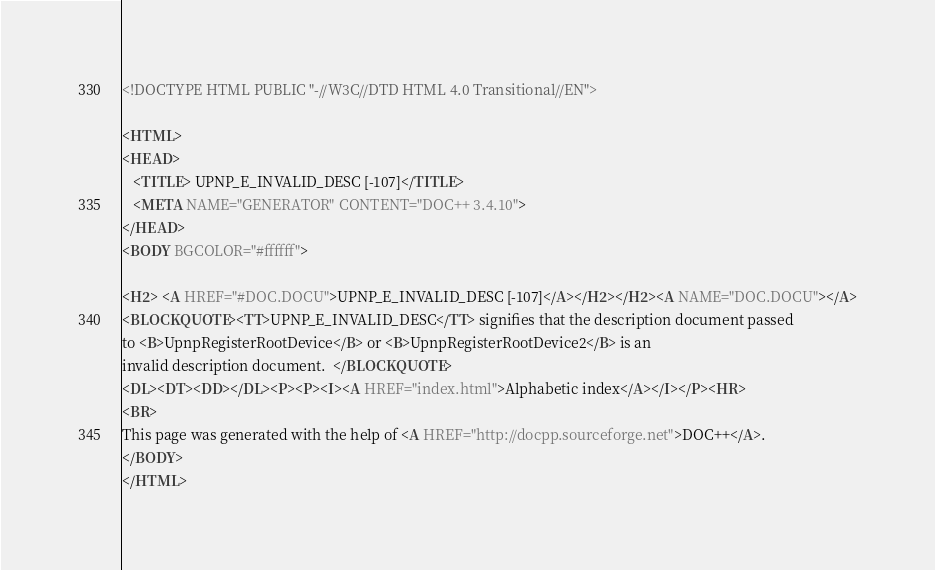<code> <loc_0><loc_0><loc_500><loc_500><_HTML_><!DOCTYPE HTML PUBLIC "-//W3C//DTD HTML 4.0 Transitional//EN">

<HTML>
<HEAD>
   <TITLE> UPNP_E_INVALID_DESC [-107]</TITLE>
   <META NAME="GENERATOR" CONTENT="DOC++ 3.4.10">
</HEAD>
<BODY BGCOLOR="#ffffff">

<H2> <A HREF="#DOC.DOCU">UPNP_E_INVALID_DESC [-107]</A></H2></H2><A NAME="DOC.DOCU"></A>
<BLOCKQUOTE><TT>UPNP_E_INVALID_DESC</TT> signifies that the description document passed
to <B>UpnpRegisterRootDevice</B> or <B>UpnpRegisterRootDevice2</B> is an 
invalid description document.  </BLOCKQUOTE>
<DL><DT><DD></DL><P><P><I><A HREF="index.html">Alphabetic index</A></I></P><HR>
<BR>
This page was generated with the help of <A HREF="http://docpp.sourceforge.net">DOC++</A>.
</BODY>
</HTML>
</code> 